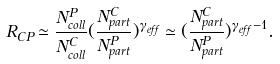Convert formula to latex. <formula><loc_0><loc_0><loc_500><loc_500>R _ { C P } \simeq \frac { N ^ { P } _ { c o l l } } { N ^ { C } _ { c o l l } } ( \frac { N ^ { C } _ { p a r t } } { N ^ { P } _ { p a r t } } ) ^ { \gamma _ { e f f } } \simeq ( \frac { N ^ { C } _ { p a r t } } { N ^ { P } _ { p a r t } } ) ^ { \gamma _ { e f f } - 1 } .</formula> 